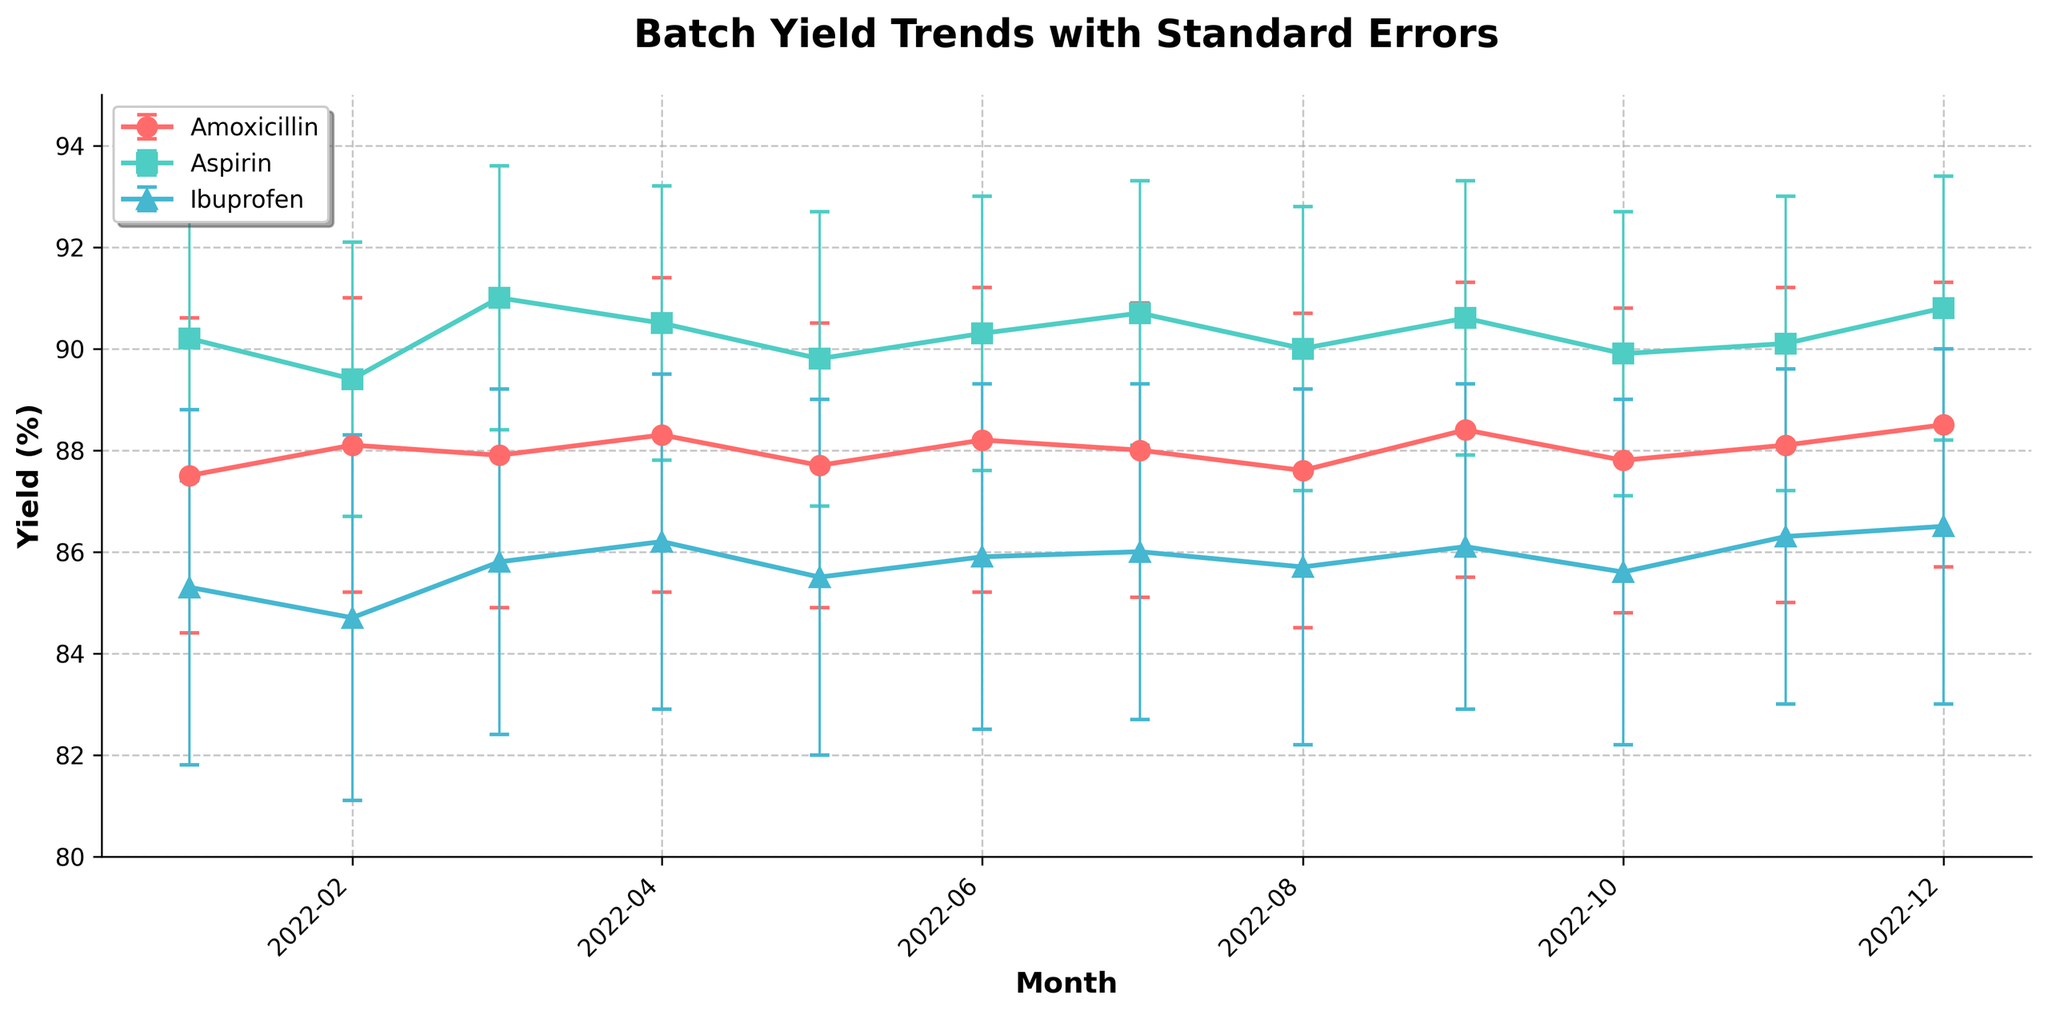What's the title of the figure? The title of the figure is usually located at the top of the chart. In this case, it indicates what the figure is about.
Answer: Batch Yield Trends with Standard Errors What is the yield percentage of Aspirin in December 2022? To find this, locate the December 2022 data point for Aspirin on the x-axis and read the corresponding yield percentage on the y-axis.
Answer: 90.8% Which batch has the highest average yield percentage over the year? To determine this, calculate the average yield percentage for each batch by summing up the yield percentages for all months and dividing by the number of months (12). Compare the averages for Amoxicillin, Aspirin, and Ibuprofen.
Answer: Aspirin Between which months did Amoxicillin yield show the most substantial increase? Compare the yield percentages of Amoxicillin between consecutive months to find the pair of months where the difference in yield percentage is the greatest.
Answer: August to September Which batch had the highest variability in yield as indicated by standard errors throughout the year? To find this, examine the error bars associated with each batch. Calculate the average standard error for each batch and compare them. The batch with the highest average standard error has the most variability.
Answer: Ibuprofen Does Ibuprofen yield exhibit any significant trends (increase or decrease) over the year? Check the line representing Ibuprofen from January to December and observe if there's a general increasing or decreasing trend across the months.
Answer: No significant trend Is there any month where all three batches yielded a percentage within 1% of each other? Compare the yield percentages of Amoxicillin, Aspirin, and Ibuprofen month by month to see if any month shows all three yields within a 1% range.
Answer: No How does the standard error for Aspirin in November compare to its standard error in December? Compare the length of the error bars for Aspirin in November and December by looking at the vertical lines originating from the data points for these months.
Answer: Higher in November Which month had the lowest yield percentage for Ibuprofen and what was that percentage? Locate the lowest data point for Ibuprofen by scanning the line graph and yield percentages. Identify the corresponding month.
Answer: February, 84.7% Comparing January and December, which batch shows the most improvement in yield percentage? Calculate the difference in yield percentages from January to December for each batch and identify which has the highest positive change.
Answer: Ibuprofen 